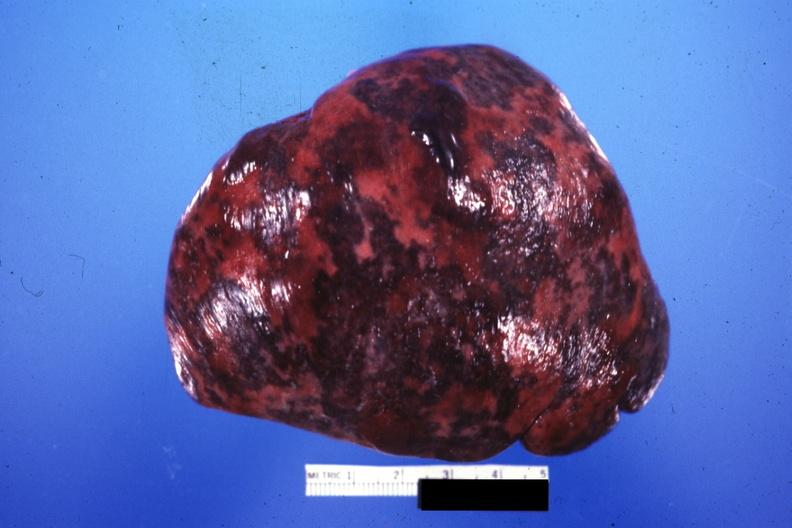s this present?
Answer the question using a single word or phrase. No 